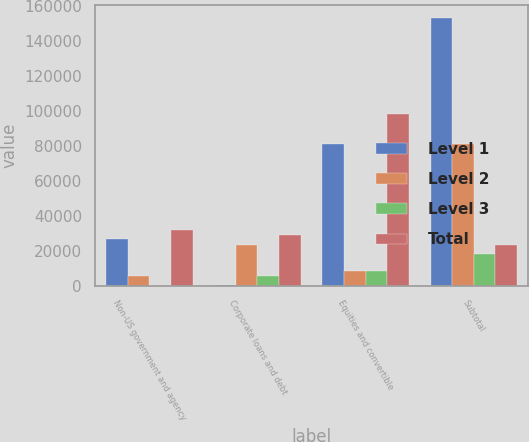<chart> <loc_0><loc_0><loc_500><loc_500><stacked_bar_chart><ecel><fcel>Non-US government and agency<fcel>Corporate loans and debt<fcel>Equities and convertible<fcel>Subtotal<nl><fcel>Level 1<fcel>26500<fcel>218<fcel>81252<fcel>153001<nl><fcel>Level 2<fcel>5260<fcel>23344<fcel>8271<fcel>80723<nl><fcel>Level 3<fcel>12<fcel>5242<fcel>8549<fcel>18131<nl><fcel>Total<fcel>31772<fcel>28804<fcel>98072<fcel>23344<nl></chart> 